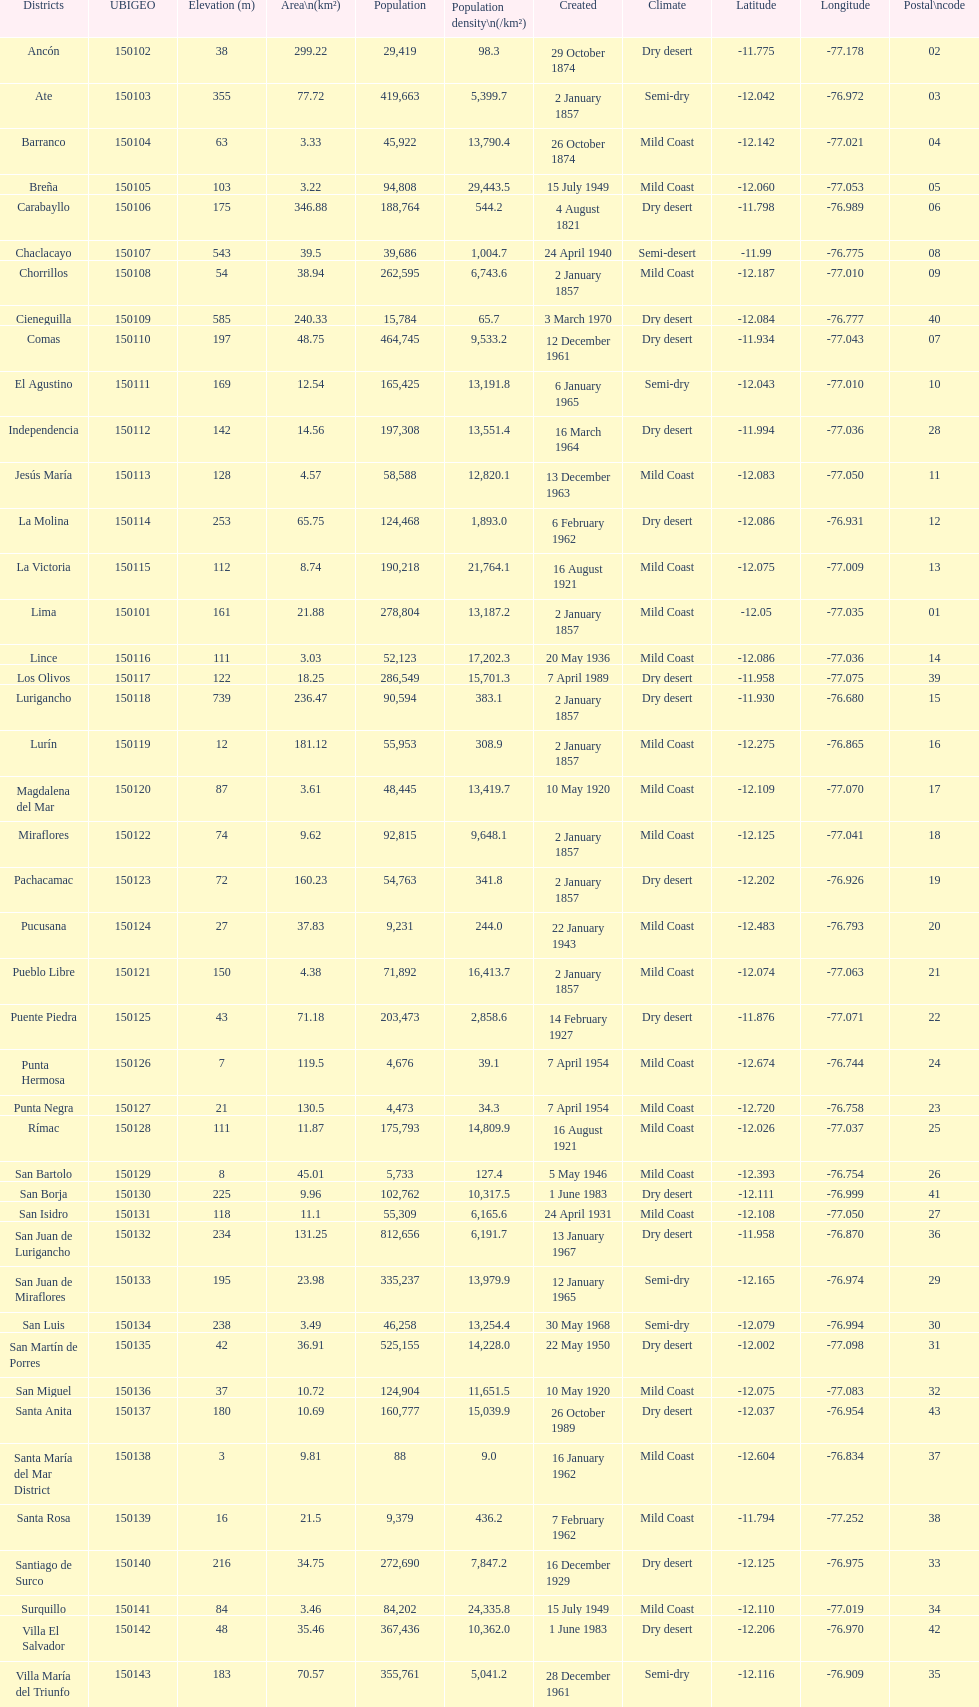How many districts are there in this city? 43. 